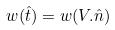Convert formula to latex. <formula><loc_0><loc_0><loc_500><loc_500>w ( \hat { t } ) = w ( V . \hat { n } )</formula> 